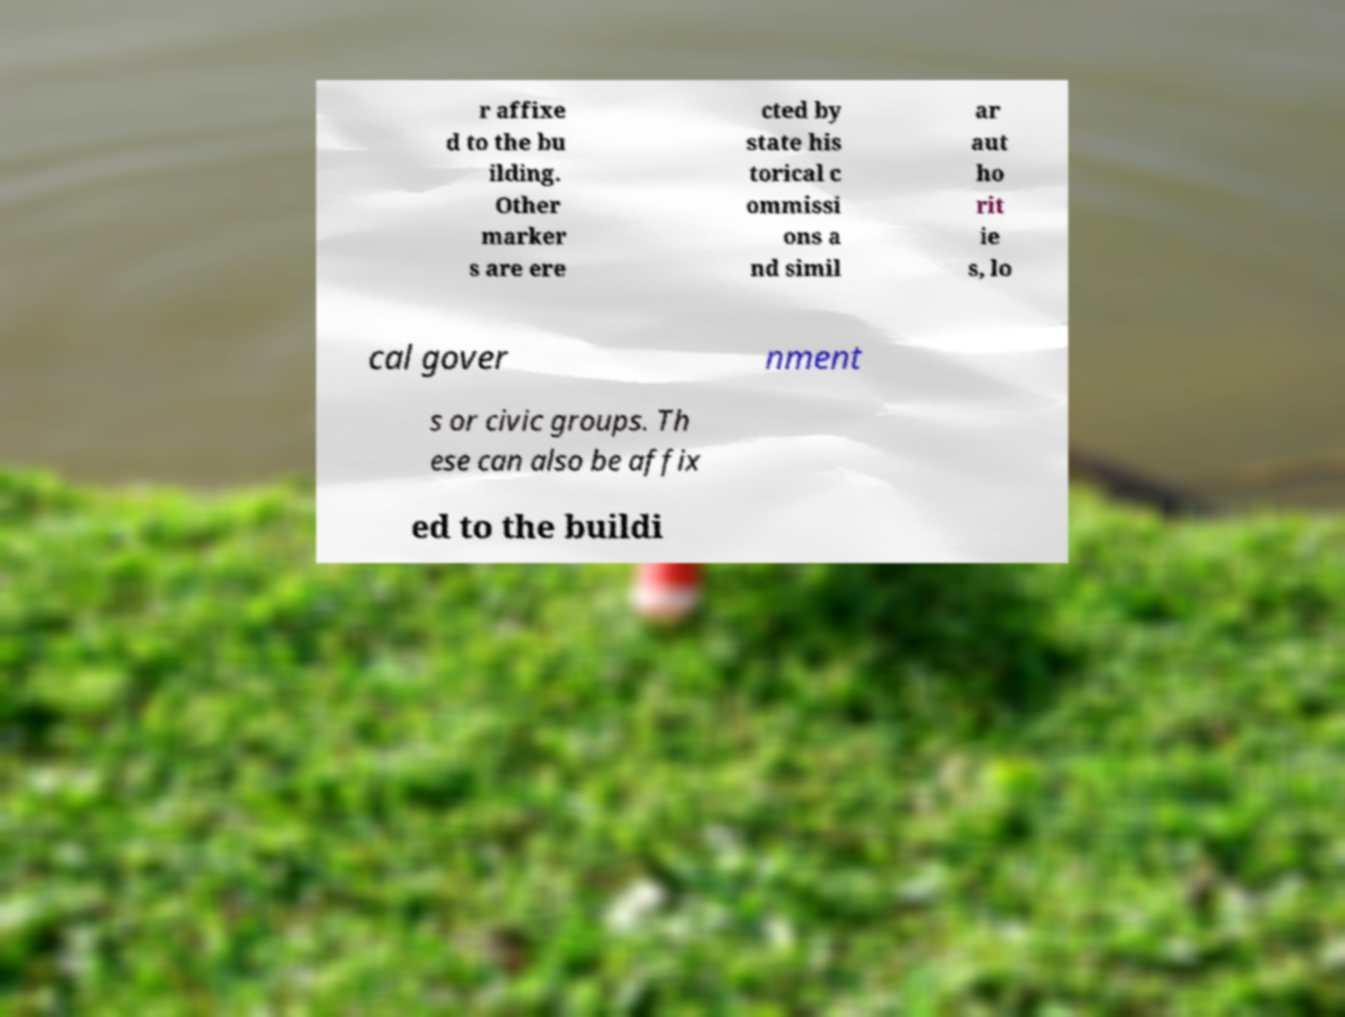Please identify and transcribe the text found in this image. r affixe d to the bu ilding. Other marker s are ere cted by state his torical c ommissi ons a nd simil ar aut ho rit ie s, lo cal gover nment s or civic groups. Th ese can also be affix ed to the buildi 